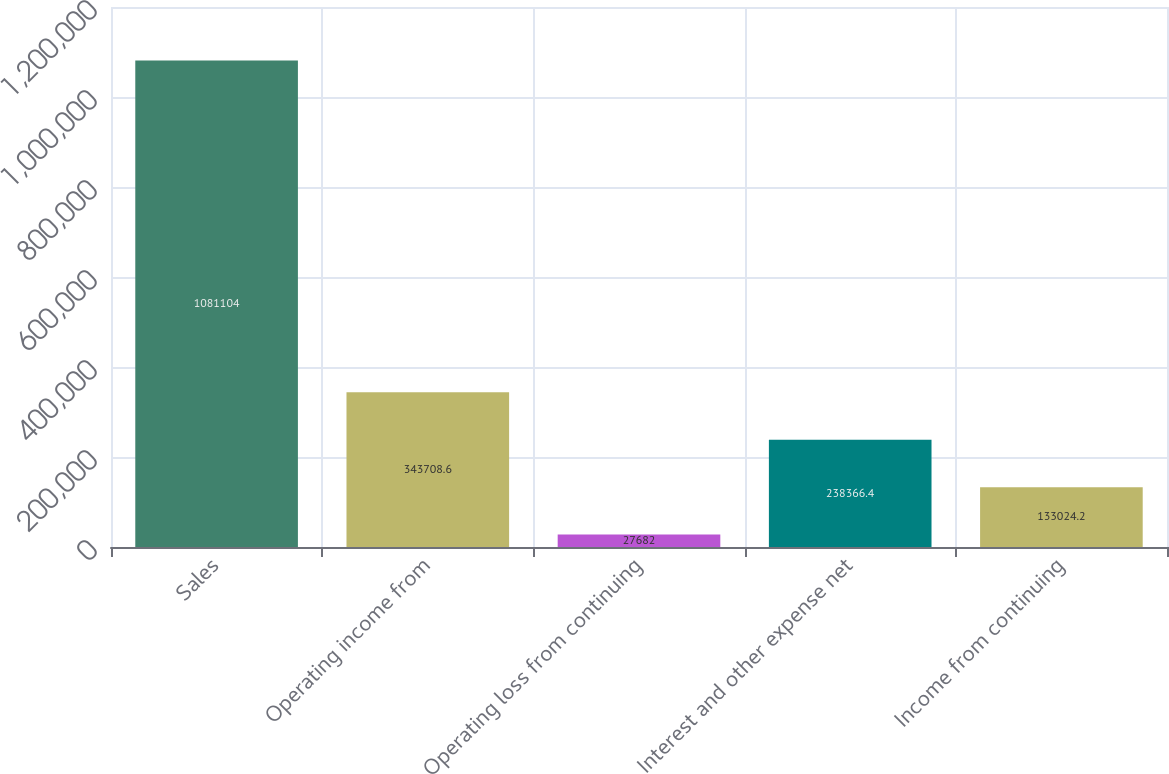Convert chart to OTSL. <chart><loc_0><loc_0><loc_500><loc_500><bar_chart><fcel>Sales<fcel>Operating income from<fcel>Operating loss from continuing<fcel>Interest and other expense net<fcel>Income from continuing<nl><fcel>1.0811e+06<fcel>343709<fcel>27682<fcel>238366<fcel>133024<nl></chart> 